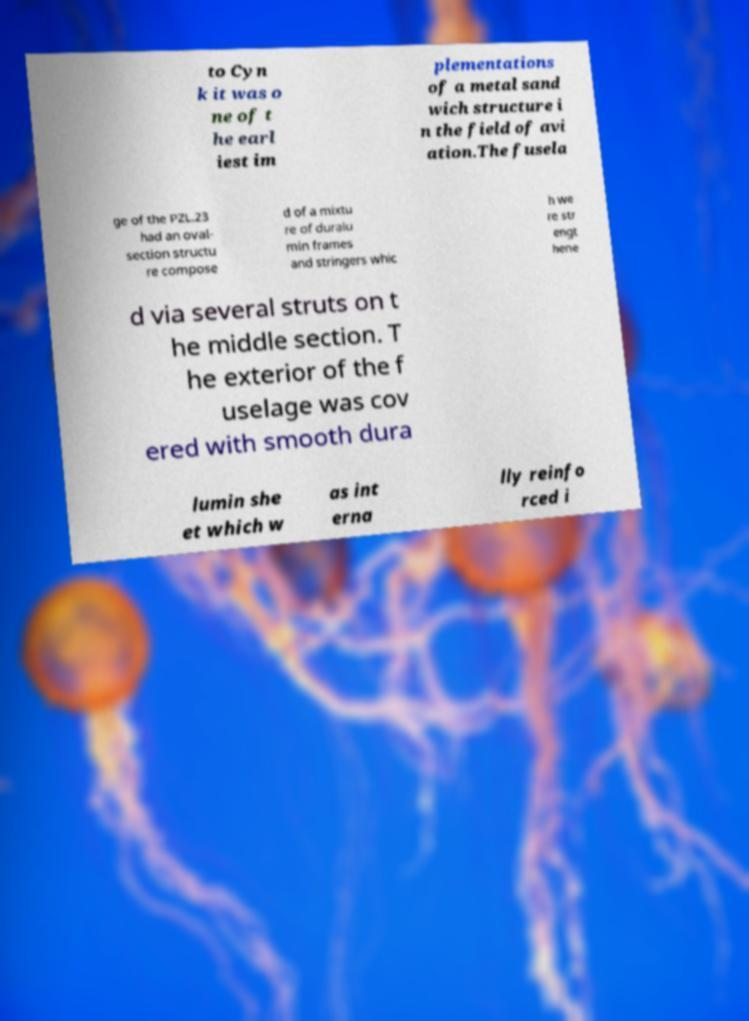Could you assist in decoding the text presented in this image and type it out clearly? to Cyn k it was o ne of t he earl iest im plementations of a metal sand wich structure i n the field of avi ation.The fusela ge of the PZL.23 had an oval- section structu re compose d of a mixtu re of duralu min frames and stringers whic h we re str engt hene d via several struts on t he middle section. T he exterior of the f uselage was cov ered with smooth dura lumin she et which w as int erna lly reinfo rced i 